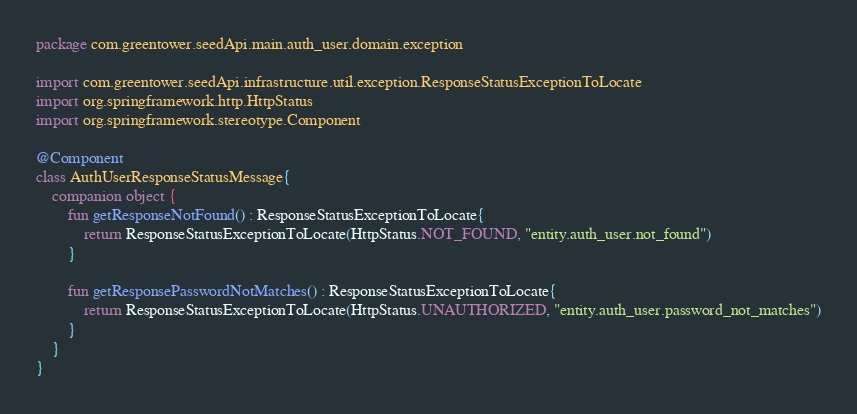Convert code to text. <code><loc_0><loc_0><loc_500><loc_500><_Kotlin_>package com.greentower.seedApi.main.auth_user.domain.exception

import com.greentower.seedApi.infrastructure.util.exception.ResponseStatusExceptionToLocate
import org.springframework.http.HttpStatus
import org.springframework.stereotype.Component

@Component
class AuthUserResponseStatusMessage{
    companion object {
        fun getResponseNotFound() : ResponseStatusExceptionToLocate{
            return ResponseStatusExceptionToLocate(HttpStatus.NOT_FOUND, "entity.auth_user.not_found")
        }

        fun getResponsePasswordNotMatches() : ResponseStatusExceptionToLocate{
            return ResponseStatusExceptionToLocate(HttpStatus.UNAUTHORIZED, "entity.auth_user.password_not_matches")
        }
    }
}</code> 